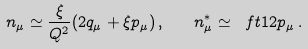<formula> <loc_0><loc_0><loc_500><loc_500>n _ { \mu } \simeq \frac { \xi } { Q ^ { 2 } } ( 2 q _ { \mu } + \xi p _ { \mu } ) \, , \quad n ^ { \ast } _ { \mu } \simeq \ f t 1 2 p _ { \mu } \, .</formula> 